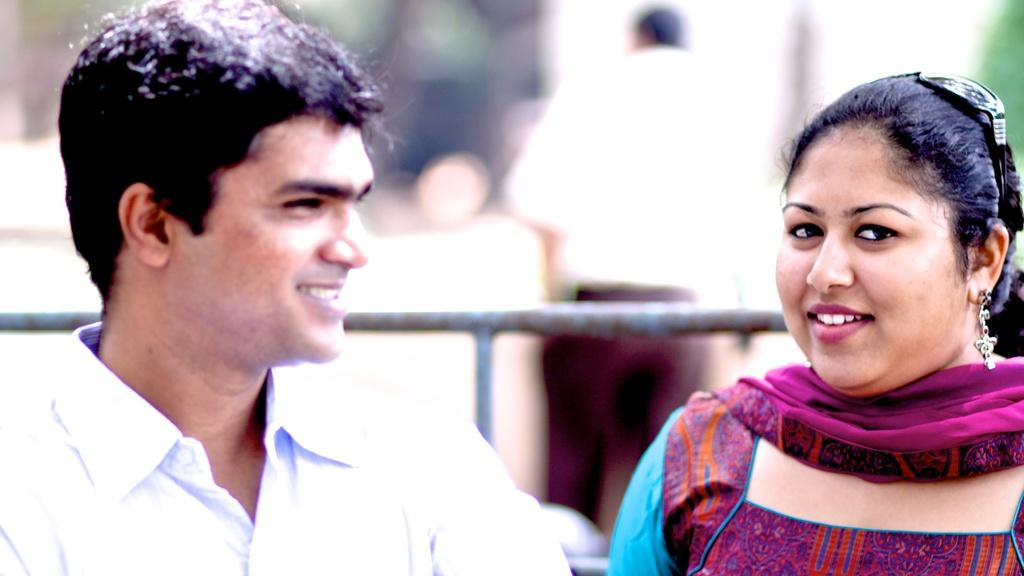How many people are present in the image? There are two people in the image. What is the facial expression of the people in the image? The two people are smiling. Can you describe the background of the image? There is a person and objects in the background of the image, and the background is blurry. What degree does the yak have in the image? There is no yak present in the image, so it cannot have a degree. 